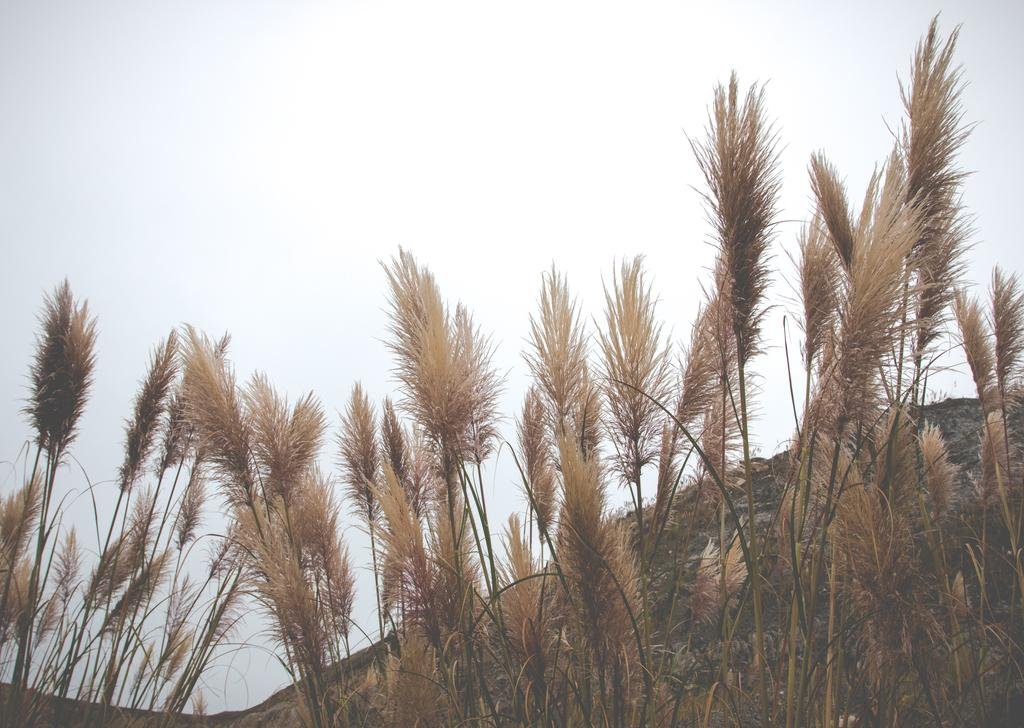What type of plants are in the image? The plants in the image are in brown color. What can be seen in the background of the image? There is a mountain in the background of the image. What is visible at the top of the image? The sky is visible at the top of the image. Can you see any veins in the plants in the image? There are no veins visible in the plants in the image, as plants do not have veins like animals do. What type of rice is being grown in the image? There is no rice present in the image; it features plants and a mountain in the background. 